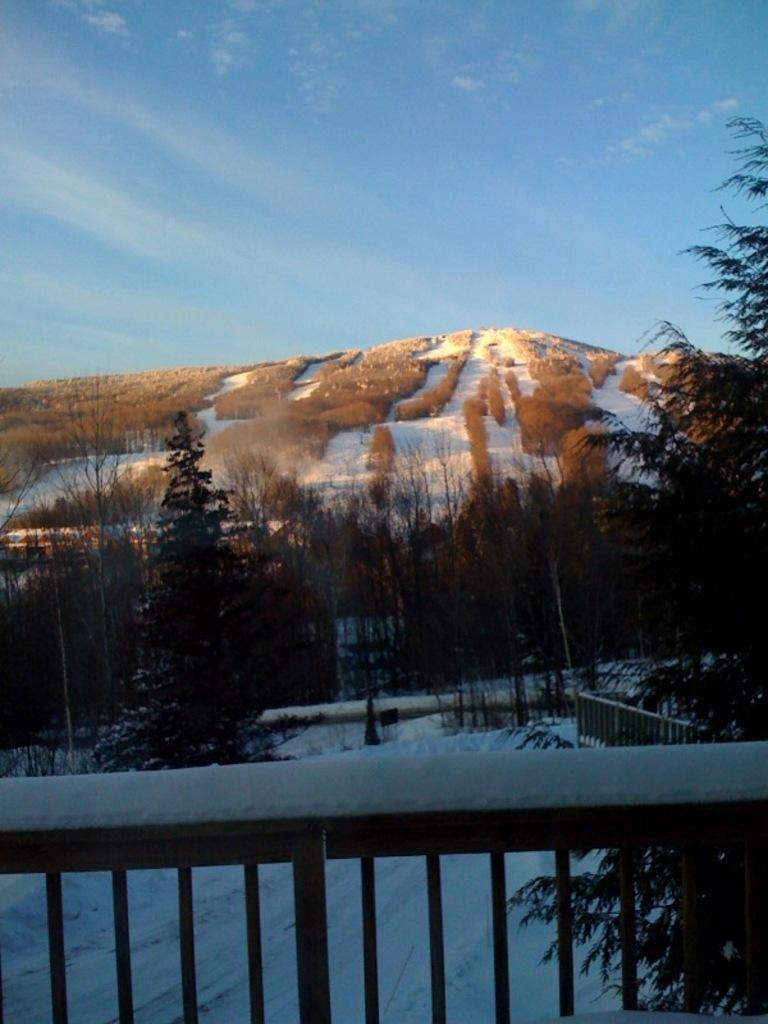What type of structure can be seen in the image? There are railings in the image, which suggests a structure like a staircase or balcony. What is the weather like in the image? There is snow visible in the image, indicating a cold or wintry environment. What type of natural elements are present in the image? There are trees and a hill visible in the image. What is visible in the background of the image? In the background, there is snow visible, a hill, and the sky. What type of society can be seen through the window in the image? There is no window present in the image, so it is not possible to see any society through it. Is there a band playing in the background of the image? There is no band present in the image; it features snow, trees, a hill, and railings. 